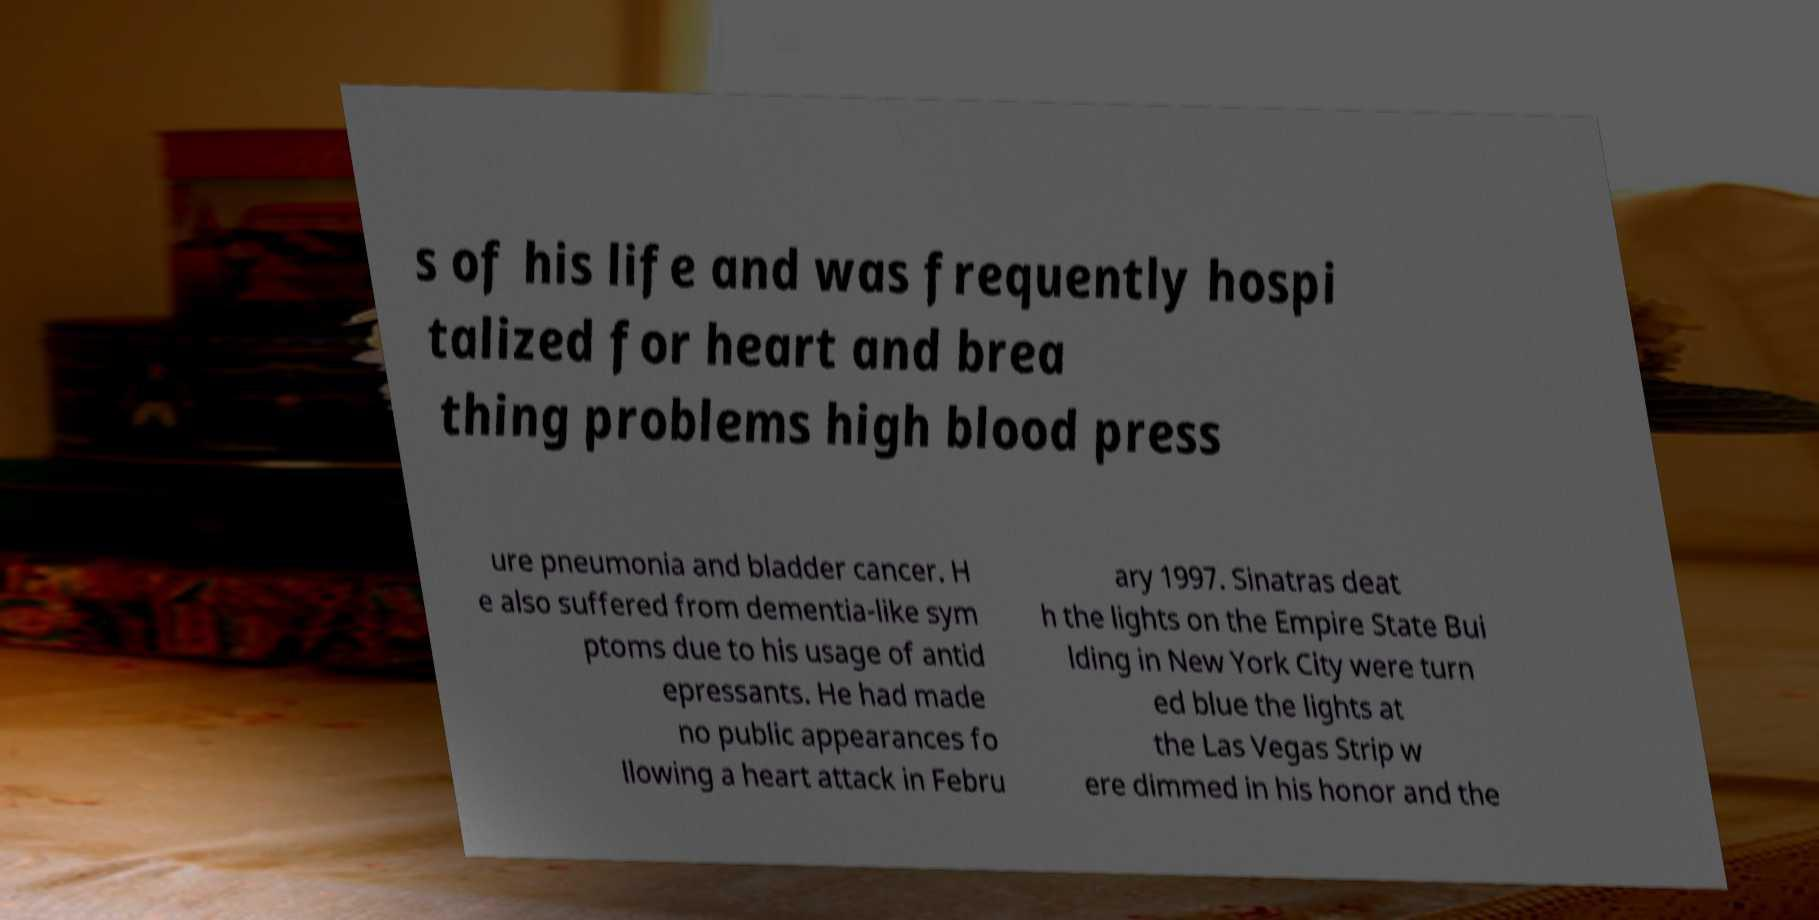Could you extract and type out the text from this image? s of his life and was frequently hospi talized for heart and brea thing problems high blood press ure pneumonia and bladder cancer. H e also suffered from dementia-like sym ptoms due to his usage of antid epressants. He had made no public appearances fo llowing a heart attack in Febru ary 1997. Sinatras deat h the lights on the Empire State Bui lding in New York City were turn ed blue the lights at the Las Vegas Strip w ere dimmed in his honor and the 